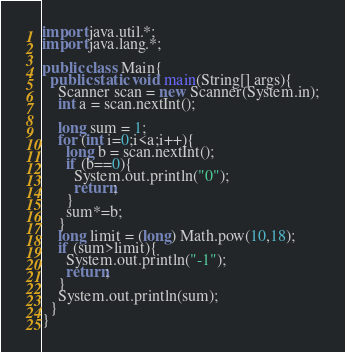<code> <loc_0><loc_0><loc_500><loc_500><_Java_>import java.util.*;
import java.lang.*;

public class Main{
  public static void main(String[] args){
    Scanner scan = new Scanner(System.in);
    int a = scan.nextInt();

    long sum = 1;
    for (int i=0;i<a;i++){
      long b = scan.nextInt();
      if (b==0){
        System.out.println("0");
        return;
      }
      sum*=b;
    }
    long limit = (long) Math.pow(10,18);
    if (sum>limit){
      System.out.println("-1");
      return;
    }
    System.out.println(sum);
  }
}
</code> 